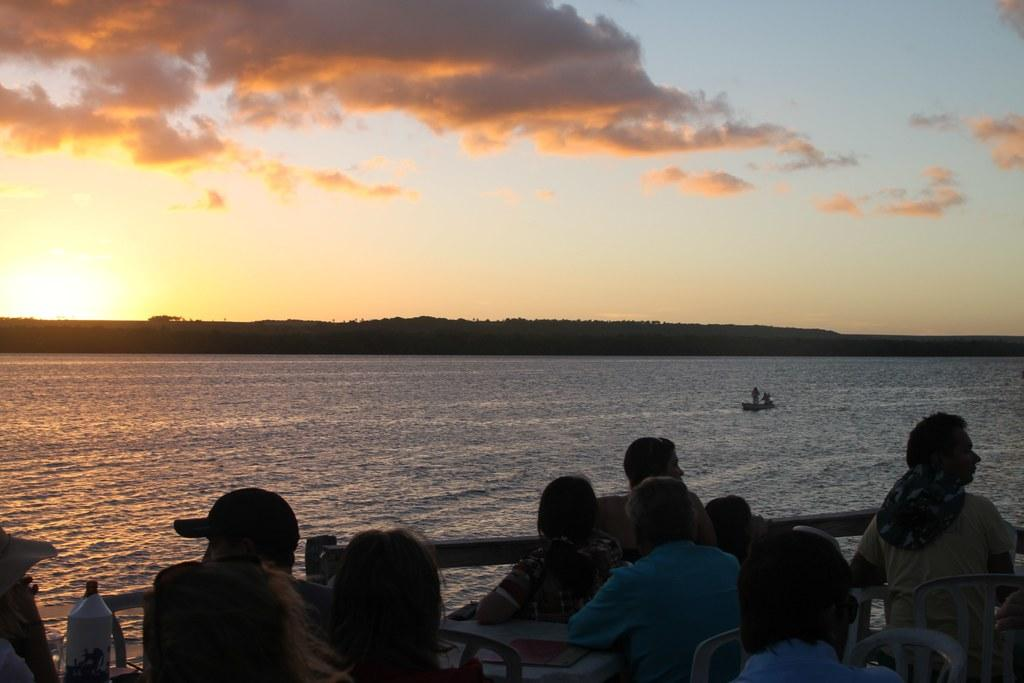What are the people in the image doing? The people in the image are sitting. What is located in the middle of the image? There is water in the middle of the image. What is visible at the top of the image? The sky is visible at the top of the image. What can be seen in the sky? Clouds are present in the sky. What type of rice is being cooked in the water in the image? There is no rice present in the image; it features people sitting near water. What flavor of bath can be seen in the image? There is no bath present in the image, so it is not possible to determine the flavor. 